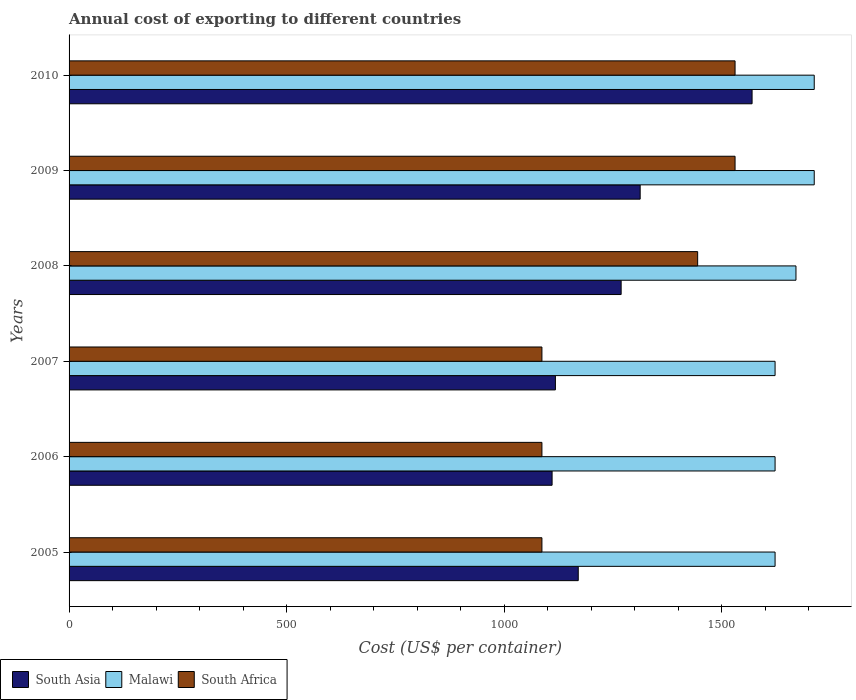How many different coloured bars are there?
Your response must be concise. 3. How many groups of bars are there?
Offer a very short reply. 6. Are the number of bars on each tick of the Y-axis equal?
Offer a very short reply. Yes. What is the total annual cost of exporting in South Asia in 2005?
Your answer should be very brief. 1170.5. Across all years, what is the maximum total annual cost of exporting in South Africa?
Give a very brief answer. 1531. Across all years, what is the minimum total annual cost of exporting in Malawi?
Ensure brevity in your answer.  1623. In which year was the total annual cost of exporting in Malawi maximum?
Keep it short and to the point. 2009. What is the total total annual cost of exporting in Malawi in the graph?
Ensure brevity in your answer.  9966. What is the difference between the total annual cost of exporting in South Asia in 2006 and that in 2010?
Offer a terse response. -459.75. What is the difference between the total annual cost of exporting in Malawi in 2010 and the total annual cost of exporting in South Africa in 2005?
Offer a very short reply. 626. What is the average total annual cost of exporting in South Africa per year?
Make the answer very short. 1294.67. In the year 2006, what is the difference between the total annual cost of exporting in Malawi and total annual cost of exporting in South Asia?
Offer a very short reply. 512.62. What is the ratio of the total annual cost of exporting in Malawi in 2007 to that in 2009?
Give a very brief answer. 0.95. Is the total annual cost of exporting in South Asia in 2006 less than that in 2010?
Your response must be concise. Yes. Is the difference between the total annual cost of exporting in Malawi in 2008 and 2010 greater than the difference between the total annual cost of exporting in South Asia in 2008 and 2010?
Your answer should be very brief. Yes. What is the difference between the highest and the lowest total annual cost of exporting in South Africa?
Your answer should be compact. 444. What does the 3rd bar from the top in 2005 represents?
Offer a terse response. South Asia. What does the 1st bar from the bottom in 2008 represents?
Your answer should be compact. South Asia. Is it the case that in every year, the sum of the total annual cost of exporting in Malawi and total annual cost of exporting in South Africa is greater than the total annual cost of exporting in South Asia?
Your answer should be very brief. Yes. How many bars are there?
Ensure brevity in your answer.  18. How many years are there in the graph?
Ensure brevity in your answer.  6. Does the graph contain any zero values?
Offer a terse response. No. Does the graph contain grids?
Give a very brief answer. No. What is the title of the graph?
Your response must be concise. Annual cost of exporting to different countries. What is the label or title of the X-axis?
Offer a very short reply. Cost (US$ per container). What is the Cost (US$ per container) of South Asia in 2005?
Your answer should be very brief. 1170.5. What is the Cost (US$ per container) of Malawi in 2005?
Ensure brevity in your answer.  1623. What is the Cost (US$ per container) of South Africa in 2005?
Make the answer very short. 1087. What is the Cost (US$ per container) in South Asia in 2006?
Keep it short and to the point. 1110.38. What is the Cost (US$ per container) of Malawi in 2006?
Make the answer very short. 1623. What is the Cost (US$ per container) in South Africa in 2006?
Make the answer very short. 1087. What is the Cost (US$ per container) of South Asia in 2007?
Make the answer very short. 1118. What is the Cost (US$ per container) of Malawi in 2007?
Offer a very short reply. 1623. What is the Cost (US$ per container) of South Africa in 2007?
Ensure brevity in your answer.  1087. What is the Cost (US$ per container) in South Asia in 2008?
Offer a terse response. 1269.12. What is the Cost (US$ per container) of Malawi in 2008?
Your answer should be very brief. 1671. What is the Cost (US$ per container) in South Africa in 2008?
Provide a short and direct response. 1445. What is the Cost (US$ per container) in South Asia in 2009?
Offer a terse response. 1312.88. What is the Cost (US$ per container) of Malawi in 2009?
Provide a succinct answer. 1713. What is the Cost (US$ per container) of South Africa in 2009?
Offer a very short reply. 1531. What is the Cost (US$ per container) of South Asia in 2010?
Give a very brief answer. 1570.12. What is the Cost (US$ per container) of Malawi in 2010?
Provide a short and direct response. 1713. What is the Cost (US$ per container) of South Africa in 2010?
Provide a succinct answer. 1531. Across all years, what is the maximum Cost (US$ per container) in South Asia?
Give a very brief answer. 1570.12. Across all years, what is the maximum Cost (US$ per container) in Malawi?
Provide a succinct answer. 1713. Across all years, what is the maximum Cost (US$ per container) of South Africa?
Offer a terse response. 1531. Across all years, what is the minimum Cost (US$ per container) in South Asia?
Provide a succinct answer. 1110.38. Across all years, what is the minimum Cost (US$ per container) in Malawi?
Provide a succinct answer. 1623. Across all years, what is the minimum Cost (US$ per container) in South Africa?
Make the answer very short. 1087. What is the total Cost (US$ per container) in South Asia in the graph?
Offer a very short reply. 7551. What is the total Cost (US$ per container) in Malawi in the graph?
Your response must be concise. 9966. What is the total Cost (US$ per container) in South Africa in the graph?
Your answer should be compact. 7768. What is the difference between the Cost (US$ per container) of South Asia in 2005 and that in 2006?
Ensure brevity in your answer.  60.12. What is the difference between the Cost (US$ per container) of South Asia in 2005 and that in 2007?
Ensure brevity in your answer.  52.5. What is the difference between the Cost (US$ per container) of South Asia in 2005 and that in 2008?
Provide a succinct answer. -98.62. What is the difference between the Cost (US$ per container) of Malawi in 2005 and that in 2008?
Provide a short and direct response. -48. What is the difference between the Cost (US$ per container) of South Africa in 2005 and that in 2008?
Keep it short and to the point. -358. What is the difference between the Cost (US$ per container) in South Asia in 2005 and that in 2009?
Give a very brief answer. -142.38. What is the difference between the Cost (US$ per container) in Malawi in 2005 and that in 2009?
Offer a very short reply. -90. What is the difference between the Cost (US$ per container) of South Africa in 2005 and that in 2009?
Your answer should be compact. -444. What is the difference between the Cost (US$ per container) in South Asia in 2005 and that in 2010?
Offer a very short reply. -399.62. What is the difference between the Cost (US$ per container) in Malawi in 2005 and that in 2010?
Offer a very short reply. -90. What is the difference between the Cost (US$ per container) in South Africa in 2005 and that in 2010?
Provide a short and direct response. -444. What is the difference between the Cost (US$ per container) in South Asia in 2006 and that in 2007?
Offer a very short reply. -7.62. What is the difference between the Cost (US$ per container) of South Africa in 2006 and that in 2007?
Provide a succinct answer. 0. What is the difference between the Cost (US$ per container) in South Asia in 2006 and that in 2008?
Your answer should be very brief. -158.75. What is the difference between the Cost (US$ per container) in Malawi in 2006 and that in 2008?
Offer a very short reply. -48. What is the difference between the Cost (US$ per container) in South Africa in 2006 and that in 2008?
Provide a succinct answer. -358. What is the difference between the Cost (US$ per container) in South Asia in 2006 and that in 2009?
Make the answer very short. -202.5. What is the difference between the Cost (US$ per container) in Malawi in 2006 and that in 2009?
Your response must be concise. -90. What is the difference between the Cost (US$ per container) in South Africa in 2006 and that in 2009?
Give a very brief answer. -444. What is the difference between the Cost (US$ per container) in South Asia in 2006 and that in 2010?
Keep it short and to the point. -459.75. What is the difference between the Cost (US$ per container) of Malawi in 2006 and that in 2010?
Offer a very short reply. -90. What is the difference between the Cost (US$ per container) in South Africa in 2006 and that in 2010?
Ensure brevity in your answer.  -444. What is the difference between the Cost (US$ per container) in South Asia in 2007 and that in 2008?
Keep it short and to the point. -151.12. What is the difference between the Cost (US$ per container) in Malawi in 2007 and that in 2008?
Your response must be concise. -48. What is the difference between the Cost (US$ per container) in South Africa in 2007 and that in 2008?
Offer a very short reply. -358. What is the difference between the Cost (US$ per container) in South Asia in 2007 and that in 2009?
Your answer should be compact. -194.88. What is the difference between the Cost (US$ per container) in Malawi in 2007 and that in 2009?
Keep it short and to the point. -90. What is the difference between the Cost (US$ per container) of South Africa in 2007 and that in 2009?
Provide a succinct answer. -444. What is the difference between the Cost (US$ per container) of South Asia in 2007 and that in 2010?
Keep it short and to the point. -452.12. What is the difference between the Cost (US$ per container) of Malawi in 2007 and that in 2010?
Ensure brevity in your answer.  -90. What is the difference between the Cost (US$ per container) of South Africa in 2007 and that in 2010?
Offer a terse response. -444. What is the difference between the Cost (US$ per container) in South Asia in 2008 and that in 2009?
Your response must be concise. -43.75. What is the difference between the Cost (US$ per container) in Malawi in 2008 and that in 2009?
Your answer should be very brief. -42. What is the difference between the Cost (US$ per container) in South Africa in 2008 and that in 2009?
Provide a short and direct response. -86. What is the difference between the Cost (US$ per container) in South Asia in 2008 and that in 2010?
Offer a very short reply. -301. What is the difference between the Cost (US$ per container) of Malawi in 2008 and that in 2010?
Keep it short and to the point. -42. What is the difference between the Cost (US$ per container) of South Africa in 2008 and that in 2010?
Offer a very short reply. -86. What is the difference between the Cost (US$ per container) of South Asia in 2009 and that in 2010?
Keep it short and to the point. -257.25. What is the difference between the Cost (US$ per container) of Malawi in 2009 and that in 2010?
Your answer should be very brief. 0. What is the difference between the Cost (US$ per container) of South Africa in 2009 and that in 2010?
Keep it short and to the point. 0. What is the difference between the Cost (US$ per container) in South Asia in 2005 and the Cost (US$ per container) in Malawi in 2006?
Ensure brevity in your answer.  -452.5. What is the difference between the Cost (US$ per container) in South Asia in 2005 and the Cost (US$ per container) in South Africa in 2006?
Offer a very short reply. 83.5. What is the difference between the Cost (US$ per container) of Malawi in 2005 and the Cost (US$ per container) of South Africa in 2006?
Offer a terse response. 536. What is the difference between the Cost (US$ per container) in South Asia in 2005 and the Cost (US$ per container) in Malawi in 2007?
Ensure brevity in your answer.  -452.5. What is the difference between the Cost (US$ per container) of South Asia in 2005 and the Cost (US$ per container) of South Africa in 2007?
Ensure brevity in your answer.  83.5. What is the difference between the Cost (US$ per container) of Malawi in 2005 and the Cost (US$ per container) of South Africa in 2007?
Give a very brief answer. 536. What is the difference between the Cost (US$ per container) in South Asia in 2005 and the Cost (US$ per container) in Malawi in 2008?
Ensure brevity in your answer.  -500.5. What is the difference between the Cost (US$ per container) of South Asia in 2005 and the Cost (US$ per container) of South Africa in 2008?
Your answer should be compact. -274.5. What is the difference between the Cost (US$ per container) of Malawi in 2005 and the Cost (US$ per container) of South Africa in 2008?
Your answer should be very brief. 178. What is the difference between the Cost (US$ per container) in South Asia in 2005 and the Cost (US$ per container) in Malawi in 2009?
Offer a terse response. -542.5. What is the difference between the Cost (US$ per container) of South Asia in 2005 and the Cost (US$ per container) of South Africa in 2009?
Your response must be concise. -360.5. What is the difference between the Cost (US$ per container) of Malawi in 2005 and the Cost (US$ per container) of South Africa in 2009?
Your response must be concise. 92. What is the difference between the Cost (US$ per container) of South Asia in 2005 and the Cost (US$ per container) of Malawi in 2010?
Give a very brief answer. -542.5. What is the difference between the Cost (US$ per container) of South Asia in 2005 and the Cost (US$ per container) of South Africa in 2010?
Ensure brevity in your answer.  -360.5. What is the difference between the Cost (US$ per container) in Malawi in 2005 and the Cost (US$ per container) in South Africa in 2010?
Offer a terse response. 92. What is the difference between the Cost (US$ per container) of South Asia in 2006 and the Cost (US$ per container) of Malawi in 2007?
Your answer should be compact. -512.62. What is the difference between the Cost (US$ per container) of South Asia in 2006 and the Cost (US$ per container) of South Africa in 2007?
Your response must be concise. 23.38. What is the difference between the Cost (US$ per container) of Malawi in 2006 and the Cost (US$ per container) of South Africa in 2007?
Ensure brevity in your answer.  536. What is the difference between the Cost (US$ per container) of South Asia in 2006 and the Cost (US$ per container) of Malawi in 2008?
Provide a short and direct response. -560.62. What is the difference between the Cost (US$ per container) in South Asia in 2006 and the Cost (US$ per container) in South Africa in 2008?
Make the answer very short. -334.62. What is the difference between the Cost (US$ per container) in Malawi in 2006 and the Cost (US$ per container) in South Africa in 2008?
Offer a very short reply. 178. What is the difference between the Cost (US$ per container) of South Asia in 2006 and the Cost (US$ per container) of Malawi in 2009?
Your answer should be very brief. -602.62. What is the difference between the Cost (US$ per container) of South Asia in 2006 and the Cost (US$ per container) of South Africa in 2009?
Offer a terse response. -420.62. What is the difference between the Cost (US$ per container) of Malawi in 2006 and the Cost (US$ per container) of South Africa in 2009?
Your answer should be compact. 92. What is the difference between the Cost (US$ per container) in South Asia in 2006 and the Cost (US$ per container) in Malawi in 2010?
Give a very brief answer. -602.62. What is the difference between the Cost (US$ per container) in South Asia in 2006 and the Cost (US$ per container) in South Africa in 2010?
Ensure brevity in your answer.  -420.62. What is the difference between the Cost (US$ per container) in Malawi in 2006 and the Cost (US$ per container) in South Africa in 2010?
Your response must be concise. 92. What is the difference between the Cost (US$ per container) in South Asia in 2007 and the Cost (US$ per container) in Malawi in 2008?
Your answer should be compact. -553. What is the difference between the Cost (US$ per container) of South Asia in 2007 and the Cost (US$ per container) of South Africa in 2008?
Offer a terse response. -327. What is the difference between the Cost (US$ per container) of Malawi in 2007 and the Cost (US$ per container) of South Africa in 2008?
Ensure brevity in your answer.  178. What is the difference between the Cost (US$ per container) in South Asia in 2007 and the Cost (US$ per container) in Malawi in 2009?
Provide a short and direct response. -595. What is the difference between the Cost (US$ per container) of South Asia in 2007 and the Cost (US$ per container) of South Africa in 2009?
Make the answer very short. -413. What is the difference between the Cost (US$ per container) of Malawi in 2007 and the Cost (US$ per container) of South Africa in 2009?
Offer a terse response. 92. What is the difference between the Cost (US$ per container) of South Asia in 2007 and the Cost (US$ per container) of Malawi in 2010?
Ensure brevity in your answer.  -595. What is the difference between the Cost (US$ per container) of South Asia in 2007 and the Cost (US$ per container) of South Africa in 2010?
Provide a succinct answer. -413. What is the difference between the Cost (US$ per container) in Malawi in 2007 and the Cost (US$ per container) in South Africa in 2010?
Provide a succinct answer. 92. What is the difference between the Cost (US$ per container) of South Asia in 2008 and the Cost (US$ per container) of Malawi in 2009?
Provide a short and direct response. -443.88. What is the difference between the Cost (US$ per container) of South Asia in 2008 and the Cost (US$ per container) of South Africa in 2009?
Provide a short and direct response. -261.88. What is the difference between the Cost (US$ per container) of Malawi in 2008 and the Cost (US$ per container) of South Africa in 2009?
Make the answer very short. 140. What is the difference between the Cost (US$ per container) of South Asia in 2008 and the Cost (US$ per container) of Malawi in 2010?
Offer a terse response. -443.88. What is the difference between the Cost (US$ per container) in South Asia in 2008 and the Cost (US$ per container) in South Africa in 2010?
Keep it short and to the point. -261.88. What is the difference between the Cost (US$ per container) of Malawi in 2008 and the Cost (US$ per container) of South Africa in 2010?
Make the answer very short. 140. What is the difference between the Cost (US$ per container) in South Asia in 2009 and the Cost (US$ per container) in Malawi in 2010?
Offer a terse response. -400.12. What is the difference between the Cost (US$ per container) of South Asia in 2009 and the Cost (US$ per container) of South Africa in 2010?
Provide a short and direct response. -218.12. What is the difference between the Cost (US$ per container) of Malawi in 2009 and the Cost (US$ per container) of South Africa in 2010?
Your answer should be compact. 182. What is the average Cost (US$ per container) of South Asia per year?
Give a very brief answer. 1258.5. What is the average Cost (US$ per container) in Malawi per year?
Your response must be concise. 1661. What is the average Cost (US$ per container) of South Africa per year?
Keep it short and to the point. 1294.67. In the year 2005, what is the difference between the Cost (US$ per container) in South Asia and Cost (US$ per container) in Malawi?
Keep it short and to the point. -452.5. In the year 2005, what is the difference between the Cost (US$ per container) in South Asia and Cost (US$ per container) in South Africa?
Give a very brief answer. 83.5. In the year 2005, what is the difference between the Cost (US$ per container) of Malawi and Cost (US$ per container) of South Africa?
Make the answer very short. 536. In the year 2006, what is the difference between the Cost (US$ per container) of South Asia and Cost (US$ per container) of Malawi?
Keep it short and to the point. -512.62. In the year 2006, what is the difference between the Cost (US$ per container) of South Asia and Cost (US$ per container) of South Africa?
Make the answer very short. 23.38. In the year 2006, what is the difference between the Cost (US$ per container) of Malawi and Cost (US$ per container) of South Africa?
Make the answer very short. 536. In the year 2007, what is the difference between the Cost (US$ per container) in South Asia and Cost (US$ per container) in Malawi?
Offer a very short reply. -505. In the year 2007, what is the difference between the Cost (US$ per container) in Malawi and Cost (US$ per container) in South Africa?
Your answer should be very brief. 536. In the year 2008, what is the difference between the Cost (US$ per container) of South Asia and Cost (US$ per container) of Malawi?
Your answer should be compact. -401.88. In the year 2008, what is the difference between the Cost (US$ per container) of South Asia and Cost (US$ per container) of South Africa?
Offer a terse response. -175.88. In the year 2008, what is the difference between the Cost (US$ per container) in Malawi and Cost (US$ per container) in South Africa?
Your answer should be very brief. 226. In the year 2009, what is the difference between the Cost (US$ per container) in South Asia and Cost (US$ per container) in Malawi?
Keep it short and to the point. -400.12. In the year 2009, what is the difference between the Cost (US$ per container) of South Asia and Cost (US$ per container) of South Africa?
Offer a terse response. -218.12. In the year 2009, what is the difference between the Cost (US$ per container) in Malawi and Cost (US$ per container) in South Africa?
Offer a terse response. 182. In the year 2010, what is the difference between the Cost (US$ per container) in South Asia and Cost (US$ per container) in Malawi?
Make the answer very short. -142.88. In the year 2010, what is the difference between the Cost (US$ per container) in South Asia and Cost (US$ per container) in South Africa?
Your answer should be very brief. 39.12. In the year 2010, what is the difference between the Cost (US$ per container) in Malawi and Cost (US$ per container) in South Africa?
Your response must be concise. 182. What is the ratio of the Cost (US$ per container) in South Asia in 2005 to that in 2006?
Your answer should be very brief. 1.05. What is the ratio of the Cost (US$ per container) of Malawi in 2005 to that in 2006?
Keep it short and to the point. 1. What is the ratio of the Cost (US$ per container) of South Africa in 2005 to that in 2006?
Give a very brief answer. 1. What is the ratio of the Cost (US$ per container) in South Asia in 2005 to that in 2007?
Make the answer very short. 1.05. What is the ratio of the Cost (US$ per container) of Malawi in 2005 to that in 2007?
Give a very brief answer. 1. What is the ratio of the Cost (US$ per container) of South Africa in 2005 to that in 2007?
Offer a very short reply. 1. What is the ratio of the Cost (US$ per container) of South Asia in 2005 to that in 2008?
Your answer should be compact. 0.92. What is the ratio of the Cost (US$ per container) of Malawi in 2005 to that in 2008?
Provide a succinct answer. 0.97. What is the ratio of the Cost (US$ per container) of South Africa in 2005 to that in 2008?
Keep it short and to the point. 0.75. What is the ratio of the Cost (US$ per container) in South Asia in 2005 to that in 2009?
Give a very brief answer. 0.89. What is the ratio of the Cost (US$ per container) in Malawi in 2005 to that in 2009?
Offer a terse response. 0.95. What is the ratio of the Cost (US$ per container) of South Africa in 2005 to that in 2009?
Make the answer very short. 0.71. What is the ratio of the Cost (US$ per container) in South Asia in 2005 to that in 2010?
Ensure brevity in your answer.  0.75. What is the ratio of the Cost (US$ per container) of Malawi in 2005 to that in 2010?
Provide a short and direct response. 0.95. What is the ratio of the Cost (US$ per container) of South Africa in 2005 to that in 2010?
Offer a terse response. 0.71. What is the ratio of the Cost (US$ per container) in South Asia in 2006 to that in 2007?
Ensure brevity in your answer.  0.99. What is the ratio of the Cost (US$ per container) in Malawi in 2006 to that in 2007?
Offer a terse response. 1. What is the ratio of the Cost (US$ per container) in South Africa in 2006 to that in 2007?
Ensure brevity in your answer.  1. What is the ratio of the Cost (US$ per container) of South Asia in 2006 to that in 2008?
Ensure brevity in your answer.  0.87. What is the ratio of the Cost (US$ per container) in Malawi in 2006 to that in 2008?
Your answer should be very brief. 0.97. What is the ratio of the Cost (US$ per container) of South Africa in 2006 to that in 2008?
Your answer should be compact. 0.75. What is the ratio of the Cost (US$ per container) in South Asia in 2006 to that in 2009?
Make the answer very short. 0.85. What is the ratio of the Cost (US$ per container) in Malawi in 2006 to that in 2009?
Your response must be concise. 0.95. What is the ratio of the Cost (US$ per container) of South Africa in 2006 to that in 2009?
Provide a short and direct response. 0.71. What is the ratio of the Cost (US$ per container) of South Asia in 2006 to that in 2010?
Your answer should be very brief. 0.71. What is the ratio of the Cost (US$ per container) of Malawi in 2006 to that in 2010?
Provide a succinct answer. 0.95. What is the ratio of the Cost (US$ per container) in South Africa in 2006 to that in 2010?
Your answer should be very brief. 0.71. What is the ratio of the Cost (US$ per container) in South Asia in 2007 to that in 2008?
Keep it short and to the point. 0.88. What is the ratio of the Cost (US$ per container) in Malawi in 2007 to that in 2008?
Keep it short and to the point. 0.97. What is the ratio of the Cost (US$ per container) of South Africa in 2007 to that in 2008?
Your answer should be compact. 0.75. What is the ratio of the Cost (US$ per container) of South Asia in 2007 to that in 2009?
Provide a short and direct response. 0.85. What is the ratio of the Cost (US$ per container) of Malawi in 2007 to that in 2009?
Ensure brevity in your answer.  0.95. What is the ratio of the Cost (US$ per container) in South Africa in 2007 to that in 2009?
Keep it short and to the point. 0.71. What is the ratio of the Cost (US$ per container) of South Asia in 2007 to that in 2010?
Ensure brevity in your answer.  0.71. What is the ratio of the Cost (US$ per container) of Malawi in 2007 to that in 2010?
Your answer should be very brief. 0.95. What is the ratio of the Cost (US$ per container) of South Africa in 2007 to that in 2010?
Your answer should be very brief. 0.71. What is the ratio of the Cost (US$ per container) in South Asia in 2008 to that in 2009?
Offer a very short reply. 0.97. What is the ratio of the Cost (US$ per container) of Malawi in 2008 to that in 2009?
Your response must be concise. 0.98. What is the ratio of the Cost (US$ per container) of South Africa in 2008 to that in 2009?
Ensure brevity in your answer.  0.94. What is the ratio of the Cost (US$ per container) in South Asia in 2008 to that in 2010?
Offer a terse response. 0.81. What is the ratio of the Cost (US$ per container) in Malawi in 2008 to that in 2010?
Your response must be concise. 0.98. What is the ratio of the Cost (US$ per container) of South Africa in 2008 to that in 2010?
Keep it short and to the point. 0.94. What is the ratio of the Cost (US$ per container) of South Asia in 2009 to that in 2010?
Keep it short and to the point. 0.84. What is the difference between the highest and the second highest Cost (US$ per container) in South Asia?
Your response must be concise. 257.25. What is the difference between the highest and the second highest Cost (US$ per container) in Malawi?
Give a very brief answer. 0. What is the difference between the highest and the lowest Cost (US$ per container) in South Asia?
Your answer should be compact. 459.75. What is the difference between the highest and the lowest Cost (US$ per container) of Malawi?
Ensure brevity in your answer.  90. What is the difference between the highest and the lowest Cost (US$ per container) in South Africa?
Provide a short and direct response. 444. 